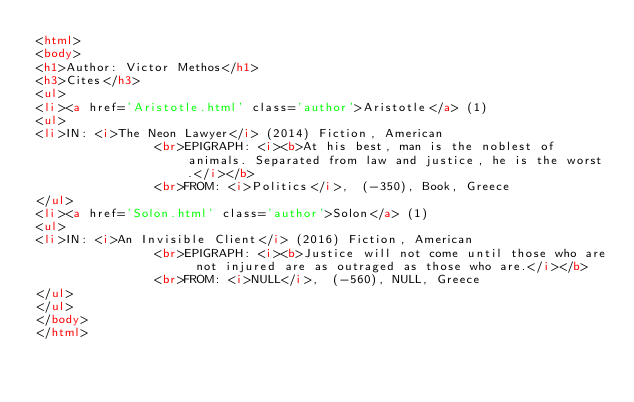Convert code to text. <code><loc_0><loc_0><loc_500><loc_500><_HTML_><html>
<body>
<h1>Author: Victor Methos</h1>
<h3>Cites</h3>
<ul>
<li><a href='Aristotle.html' class='author'>Aristotle</a> (1)
<ul>
<li>IN: <i>The Neon Lawyer</i> (2014) Fiction, American
                <br>EPIGRAPH: <i><b>At his best, man is the noblest of animals. Separated from law and justice, he is the worst.</i></b>
                <br>FROM: <i>Politics</i>,  (-350), Book, Greece
</ul>
<li><a href='Solon.html' class='author'>Solon</a> (1)
<ul>
<li>IN: <i>An Invisible Client</i> (2016) Fiction, American
                <br>EPIGRAPH: <i><b>Justice will not come until those who are not injured are as outraged as those who are.</i></b>
                <br>FROM: <i>NULL</i>,  (-560), NULL, Greece
</ul>
</ul>
</body>
</html>
</code> 